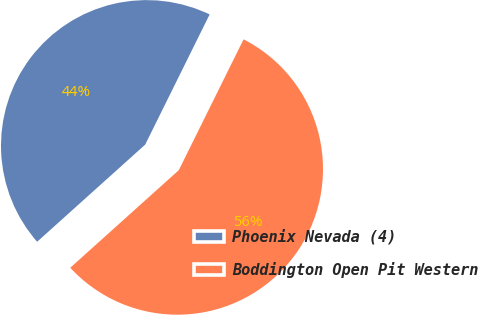Convert chart. <chart><loc_0><loc_0><loc_500><loc_500><pie_chart><fcel>Phoenix Nevada (4)<fcel>Boddington Open Pit Western<nl><fcel>43.97%<fcel>56.03%<nl></chart> 